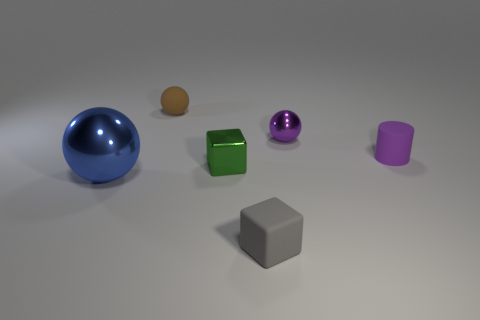There is a tiny metallic object that is behind the green metallic object; does it have the same shape as the object that is left of the small brown thing?
Offer a very short reply. Yes. What is the color of the sphere that is to the left of the gray thing and behind the large shiny sphere?
Give a very brief answer. Brown. Is the size of the sphere that is in front of the tiny purple metal thing the same as the cube that is to the left of the gray block?
Give a very brief answer. No. What number of small spheres have the same color as the small matte block?
Your response must be concise. 0. How many big things are either brown rubber balls or blue rubber balls?
Provide a succinct answer. 0. Do the small block that is in front of the big object and the blue object have the same material?
Your answer should be very brief. No. The large metallic sphere in front of the tiny brown rubber thing is what color?
Make the answer very short. Blue. Is there a brown thing that has the same size as the purple rubber cylinder?
Your response must be concise. Yes. What is the material of the gray thing that is the same size as the green block?
Make the answer very short. Rubber. Does the gray matte block have the same size as the metal ball that is in front of the tiny green shiny cube?
Ensure brevity in your answer.  No. 